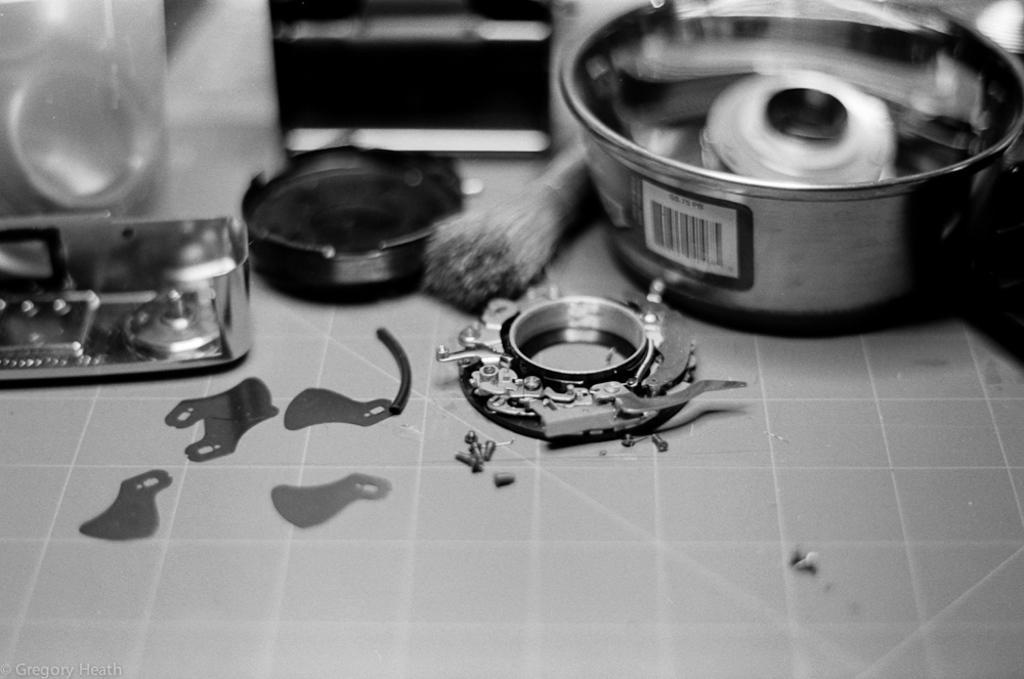Could you give a brief overview of what you see in this image? In this picture there is a bowl, brush and there are objects. At the bottom there is a tile and there is a bar code on the bowl. At the bottom left there is a text. 